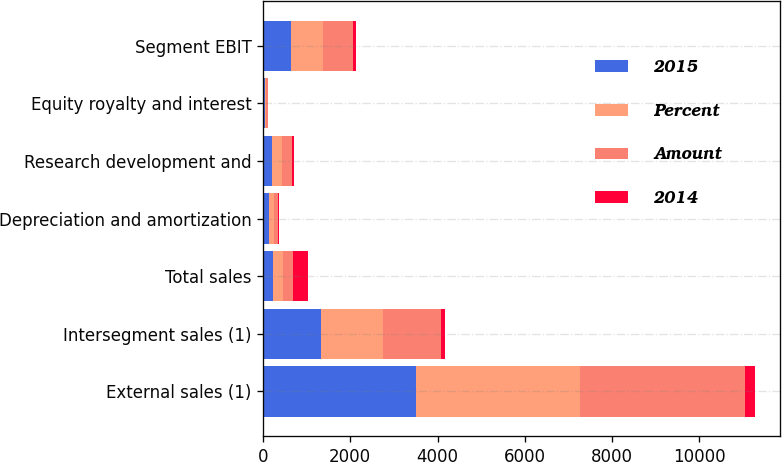Convert chart to OTSL. <chart><loc_0><loc_0><loc_500><loc_500><stacked_bar_chart><ecel><fcel>External sales (1)<fcel>Intersegment sales (1)<fcel>Total sales<fcel>Depreciation and amortization<fcel>Research development and<fcel>Equity royalty and interest<fcel>Segment EBIT<nl><fcel>2015<fcel>3514<fcel>1322<fcel>230<fcel>133<fcel>208<fcel>41<fcel>641<nl><fcel>Percent<fcel>3745<fcel>1427<fcel>230<fcel>109<fcel>236<fcel>35<fcel>727<nl><fcel>Amount<fcel>3791<fcel>1327<fcel>230<fcel>106<fcel>230<fcel>36<fcel>684<nl><fcel>2014<fcel>231<fcel>105<fcel>336<fcel>24<fcel>28<fcel>6<fcel>86<nl></chart> 